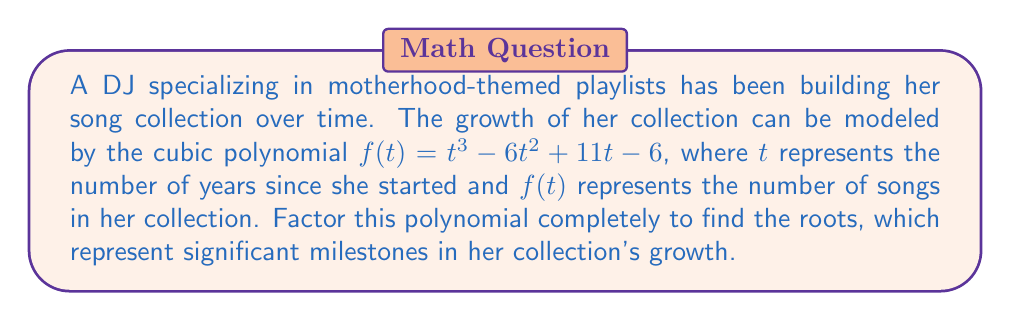Provide a solution to this math problem. To factor the cubic polynomial $f(t) = t^3 - 6t^2 + 11t - 6$, we'll follow these steps:

1) First, let's check if there's a rational root. We can use the rational root theorem to list possible roots: $\pm 1, \pm 2, \pm 3, \pm 6$

2) By testing these values, we find that $f(1) = 0$. So, $(t-1)$ is a factor.

3) We can use polynomial long division to divide $f(t)$ by $(t-1)$:

   $t^3 - 6t^2 + 11t - 6 = (t-1)(t^2 - 5t + 6)$

4) Now we need to factor the quadratic $t^2 - 5t + 6$

5) The quadratic formula gives us:
   $t = \frac{5 \pm \sqrt{25 - 24}}{2} = \frac{5 \pm 1}{2}$

6) This means the roots are 2 and 3.

Therefore, the complete factorization is:

$f(t) = (t-1)(t-2)(t-3)$

The roots are 1, 2, and 3, representing significant milestones in the growth of the DJ's song collection at 1 year, 2 years, and 3 years after starting.
Answer: $(t-1)(t-2)(t-3)$ 